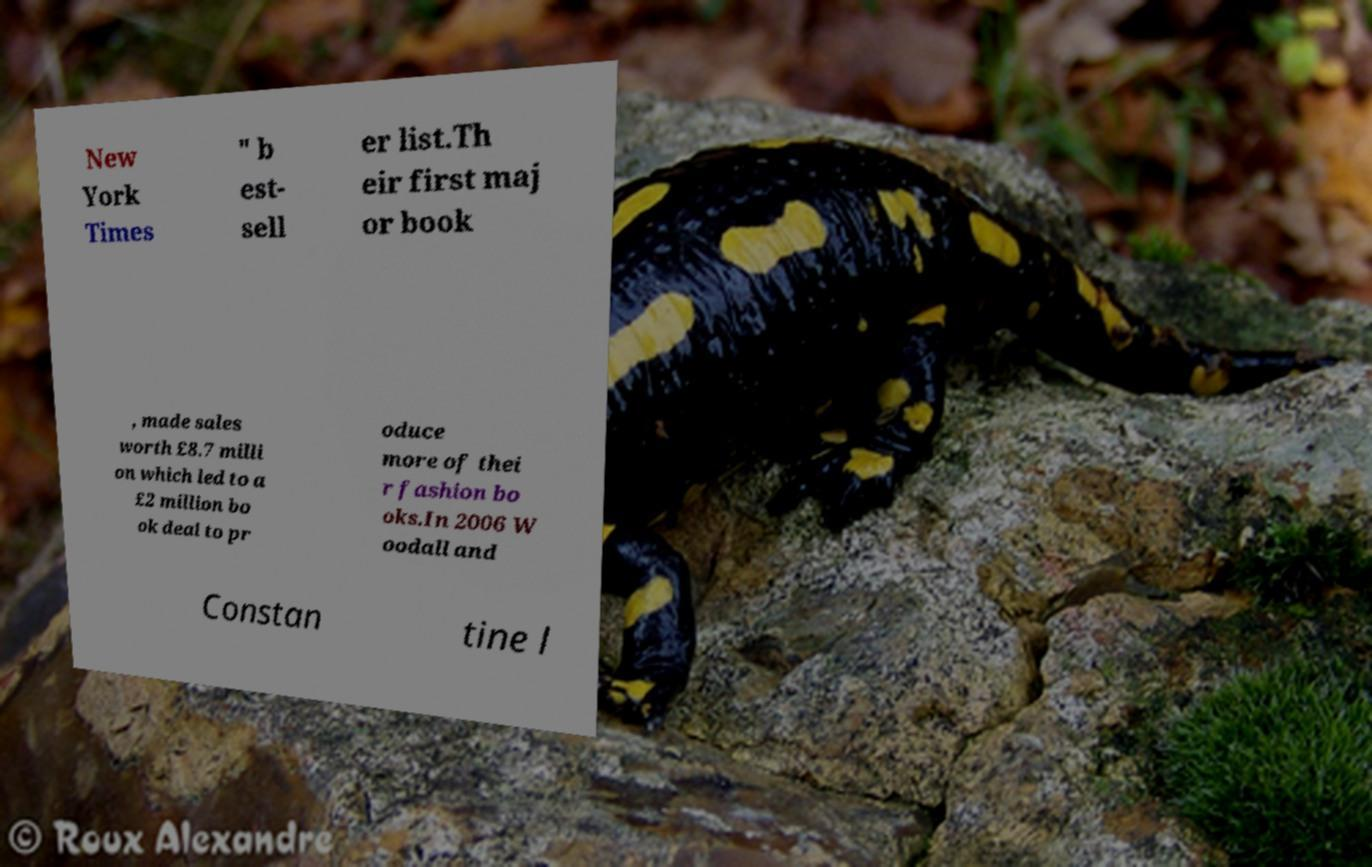Please identify and transcribe the text found in this image. New York Times " b est- sell er list.Th eir first maj or book , made sales worth £8.7 milli on which led to a £2 million bo ok deal to pr oduce more of thei r fashion bo oks.In 2006 W oodall and Constan tine l 